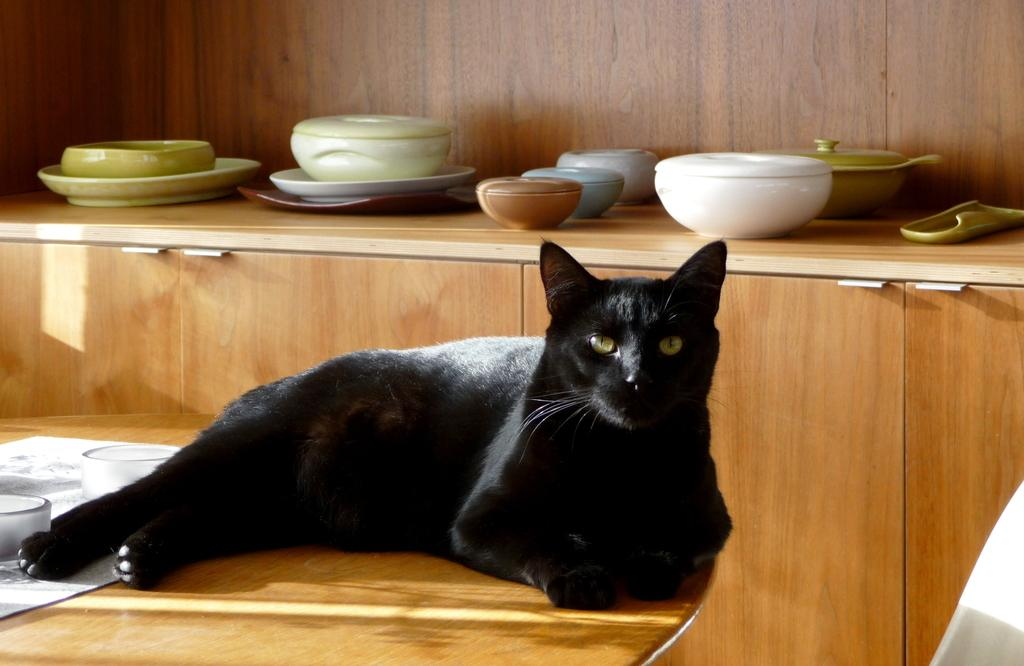What type of animal is in the image? There is a black cat in the image. Can you describe any objects or items in the background of the image? Yes, there are utensils visible in the background of the image. What type of church is depicted in the image? There is no church present in the image; it features a black cat and utensils in the background. How many snails can be seen crawling on the cat in the image? There are no snails present in the image; it features a black cat and utensils in the background. 